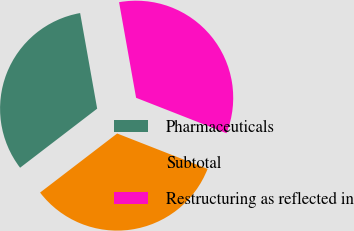Convert chart to OTSL. <chart><loc_0><loc_0><loc_500><loc_500><pie_chart><fcel>Pharmaceuticals<fcel>Subtotal<fcel>Restructuring as reflected in<nl><fcel>32.6%<fcel>33.65%<fcel>33.75%<nl></chart> 